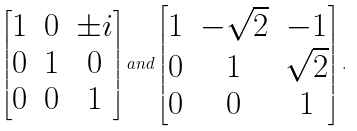Convert formula to latex. <formula><loc_0><loc_0><loc_500><loc_500>\begin{bmatrix} 1 & 0 & \pm i \\ 0 & 1 & 0 \\ 0 & 0 & 1 \end{bmatrix} a n d \begin{bmatrix} 1 & - \sqrt { 2 } & - 1 \\ 0 & 1 & \sqrt { 2 } \\ 0 & 0 & 1 \end{bmatrix} .</formula> 